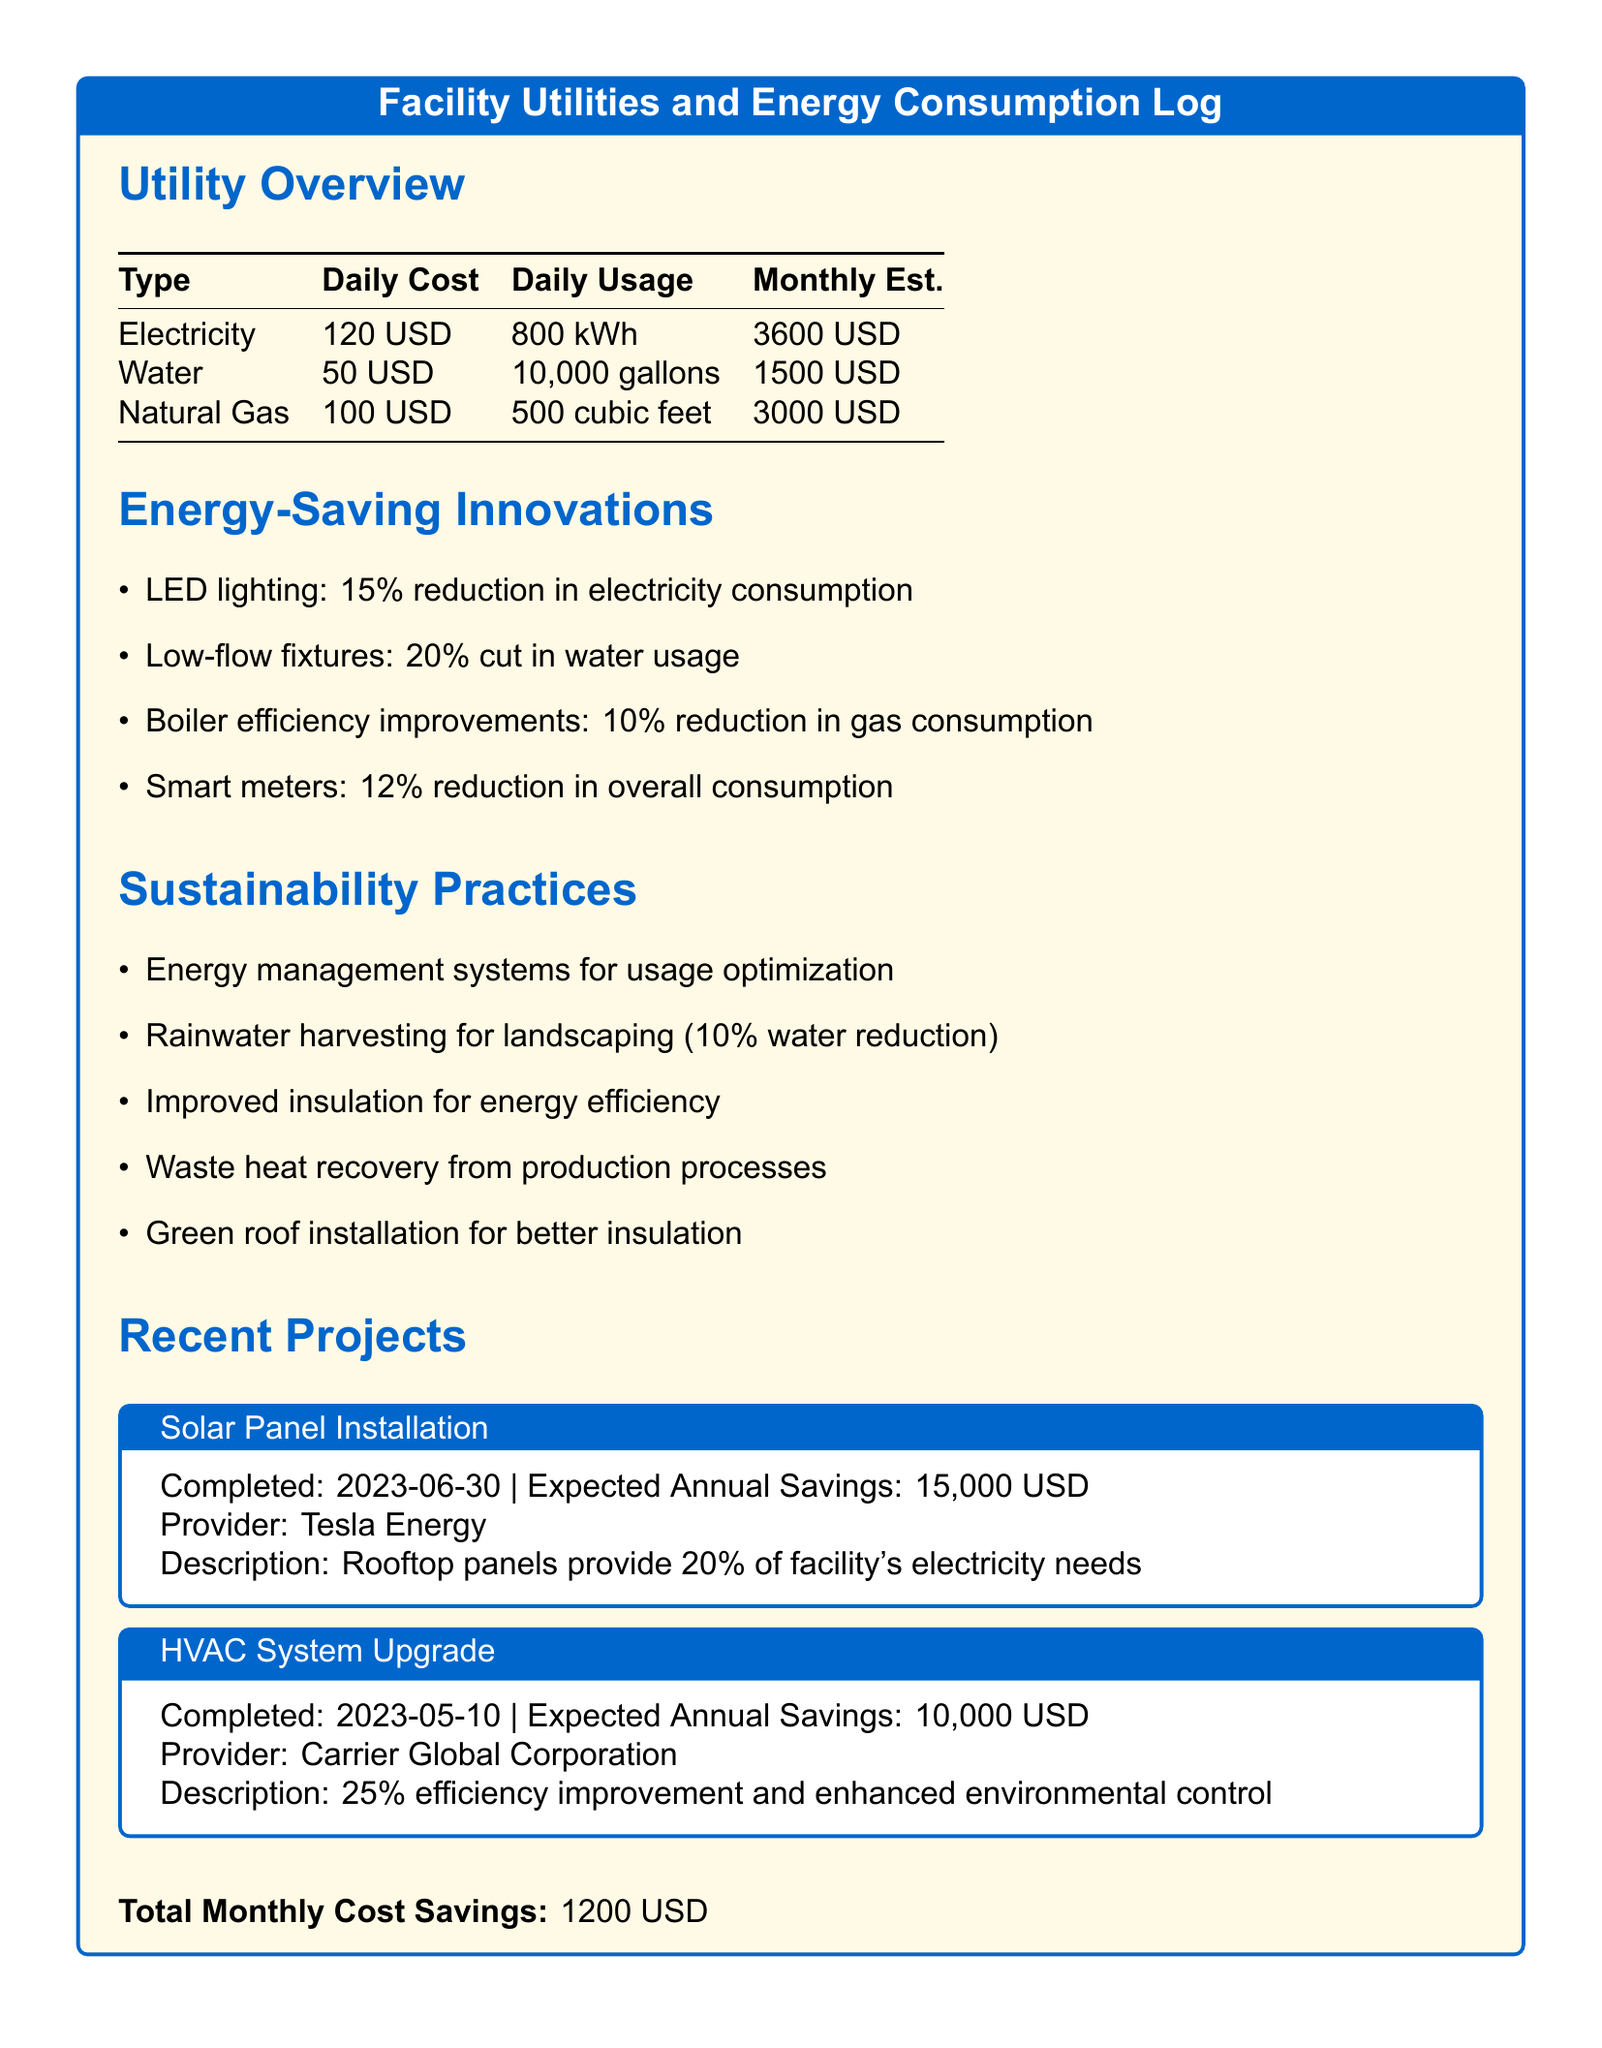What is the daily cost of electricity? The daily cost of electricity is stated in the Utility Overview section, specifically listed as 120 USD.
Answer: 120 USD What is the estimated monthly cost of water? The estimated monthly cost for water is detailed in the Utility Overview section, listed as 1500 USD.
Answer: 1500 USD What percentage reduction does LED lighting provide in electricity consumption? The Energy-Saving Innovations section specifies that LED lighting provides a 15% reduction in electricity consumption.
Answer: 15% What is the expected annual savings from the Solar Panel Installation? The expected annual savings from the Solar Panel Installation is mentioned in the Recent Projects section, as 15,000 USD.
Answer: 15,000 USD Which provider was responsible for the HVAC System Upgrade? The HVAC System Upgrade project lists Carrier Global Corporation as the provider in the Recent Projects section.
Answer: Carrier Global Corporation What are the total monthly cost savings mentioned in the document? The total monthly cost savings is clearly stated at the end of the document as 1200 USD.
Answer: 1200 USD Which energy innovation provides a 10% reduction in gas consumption? The Energy-Saving Innovations section notes that boiler efficiency improvements result in a 10% reduction in gas consumption.
Answer: Boiler efficiency improvements How much water reduction does rainwater harvesting contribute? The Sustainability Practices section indicates that rainwater harvesting contributes to a 10% reduction in water usage.
Answer: 10% What type of energy management system is mentioned for usage optimization? The sustainability practices mention “energy management systems” for usage optimization, aligning with efficiency goals.
Answer: Energy management systems 